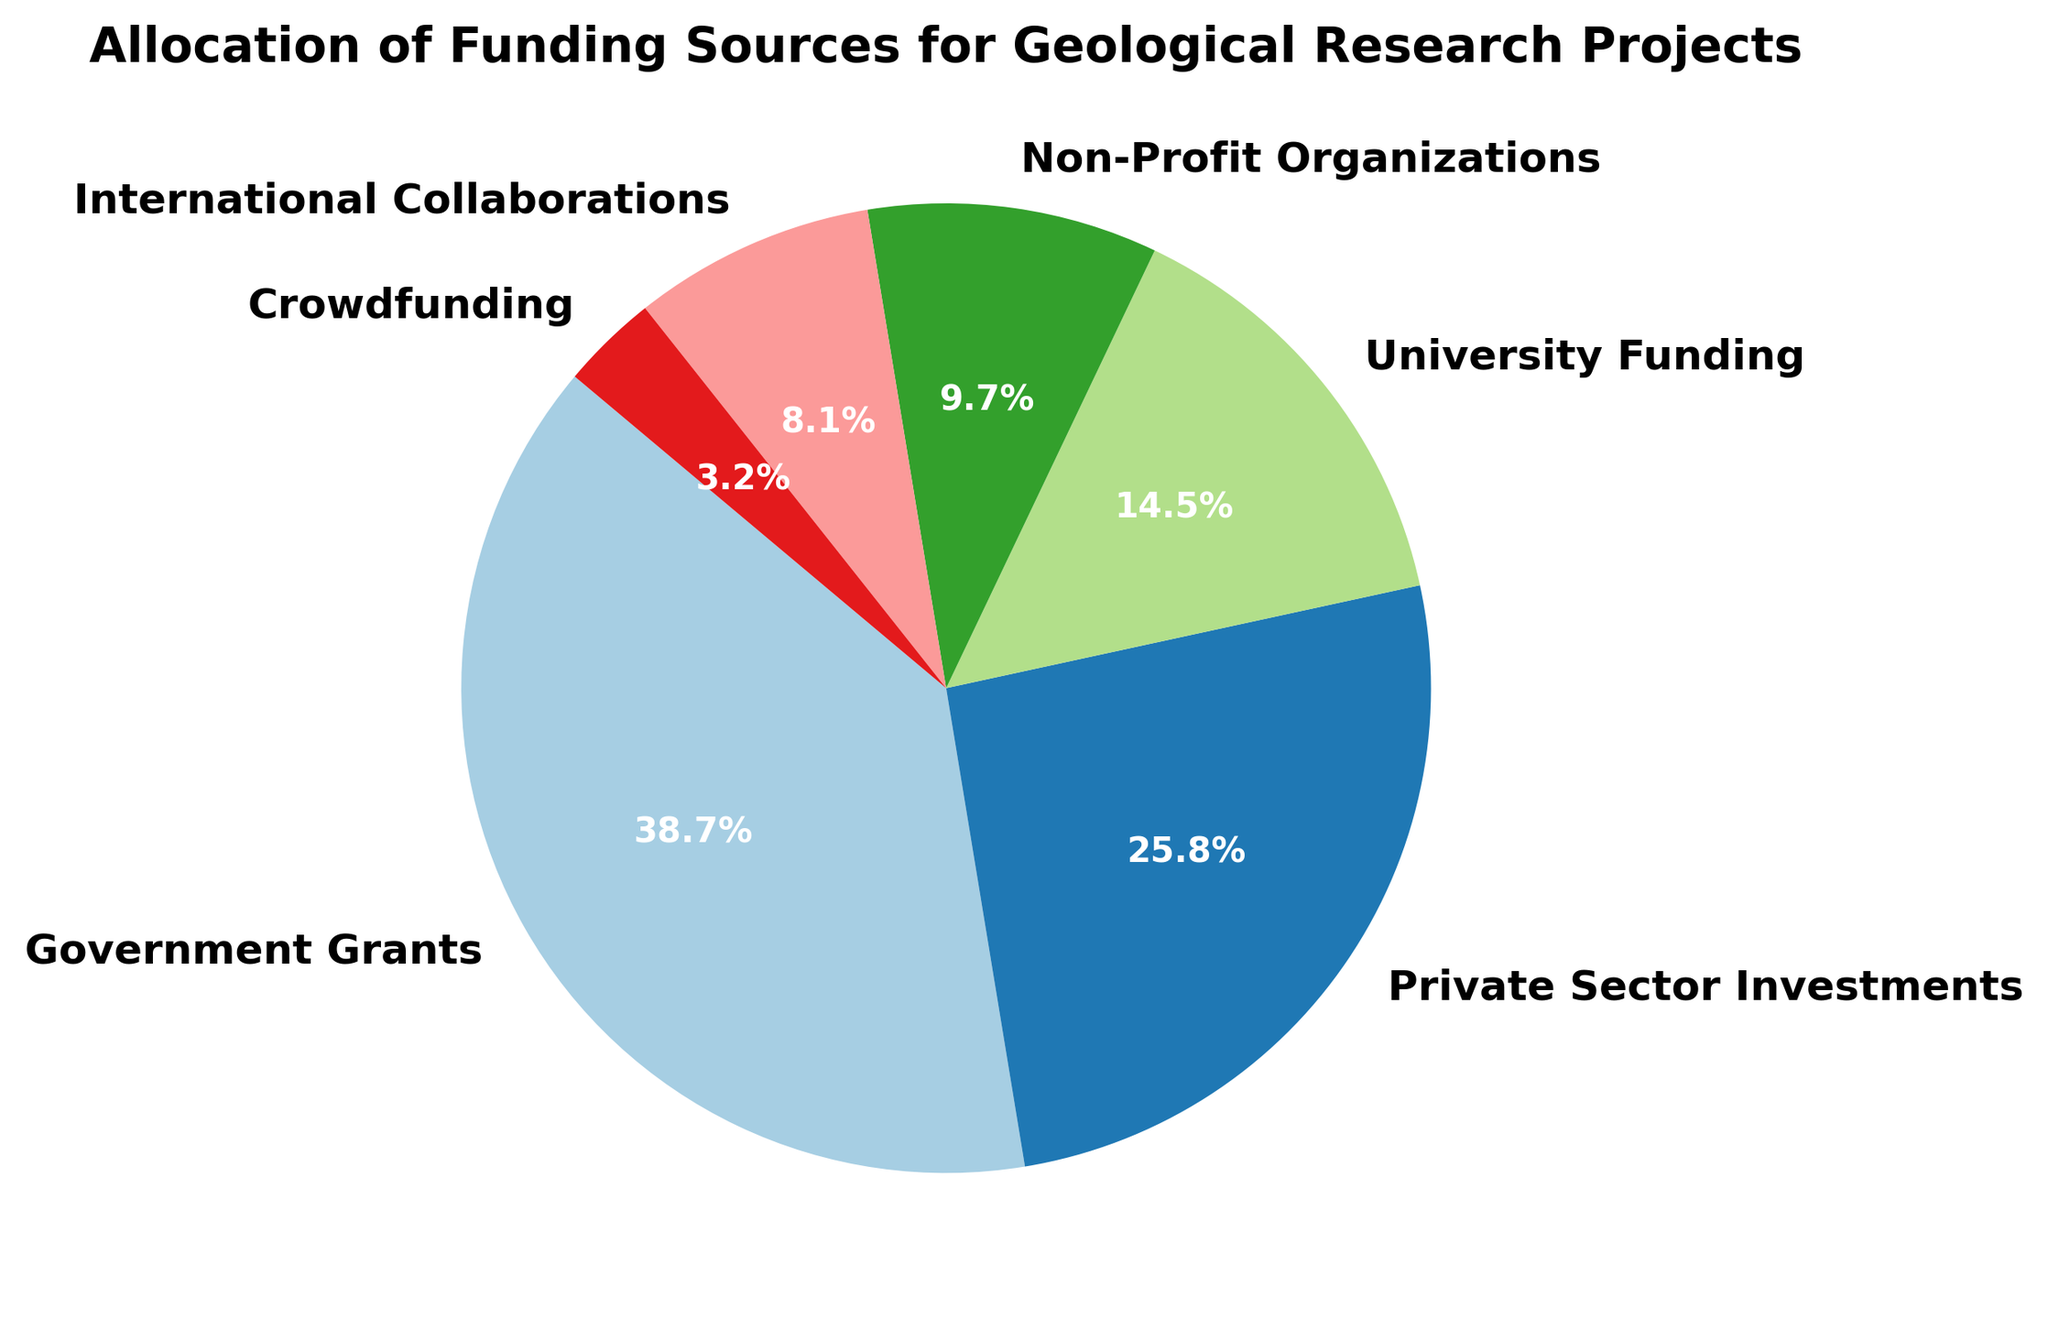What percentage of the total funding is allocated from government grants? Look at the segment labeled "Government Grants" on the pie chart. The chart shows percentages for each source, and government grants are marked as 40.0%.
Answer: 40.0% Which funding source has the smallest allocation? Identify the smallest segment in the pie chart. The segment labeled "Crowdfunding" is the smallest, with a percentage of 3.3% or an amount of 10 million USD.
Answer: Crowdfunding What is the total amount of funding raised from non-government sources? Sum the amounts from the non-government sources: Private Sector Investments (80), University Funding (45), Non-Profit Organizations (30), International Collaborations (25), and Crowdfunding (10). The total is 80 + 45 + 30 + 25 + 10 = 190 million USD.
Answer: 190 million USD How does the allocation from university funding compare to private sector investments? Compare the slice labeled "University Funding" with "Private Sector Investments". University funding is 45 million USD and private sector investments are 80 million USD. Private sector investments are larger.
Answer: Private sector investments are larger Which two funding sources together constitute exactly half of the total funding? Calculate half of the total funding first. The total funding is 120 + 80 + 45 + 30 + 25 + 10 = 310 million USD, so half is 310 / 2 = 155 million USD. The two sources that together amount to 155 million USD are Government Grants (120) and Private Sector Investments (80), summing to 120 + 80 = 200 million USD. No exact half equals 155 million USD when pairing options.
Answer: No pair sums to exactly half Which funding source allocation is closest to the combined total of international collaborations and crowdfunding? First, calculate the combined total of International Collaborations (25) and Crowdfunding (10): 25 + 10 = 35 million USD. Compare this with the other sources: University Funding at 45 million USD is the closest.
Answer: University Funding What is the difference in allocation between government grants and non-profit organizations? Subtract the amount for Non-Profit Organizations (30 million USD) from Government Grants (120 million USD): 120 - 30 = 90 million USD.
Answer: 90 million USD Among the funding sources, which one contributes slightly more than 10% to the total allocation? Look for the slice that is a bit over 10%. Both International Collaborations and Crowdfunding are significantly below this threshold. Private Sector Investments, at 25.8%, and University funding at 14.5%, are much higher. Non-Profit Organizations are 9.7%. Identifying accurate comparison results in only university being closer but more than 10%.
Answer: University funding What is the average allocation per funding source? Compute the total funding and divide it by the number of sources. The total funding is 310 million USD, and there are 6 funding sources. The average is 310 / 6 = 51.67 million USD.
Answer: 51.67 million USD If the allocation from crowdfunding were to double, what would be the new percentage share of crowdfunding? Double the current crowdfunding amount: 10 * 2 = 20 million USD. The new total funding would be 310 + 10 = 320 million USD. The new percentage share for crowdfunding would be (20 / 320) * 100 = 6.25%.
Answer: 6.25% 